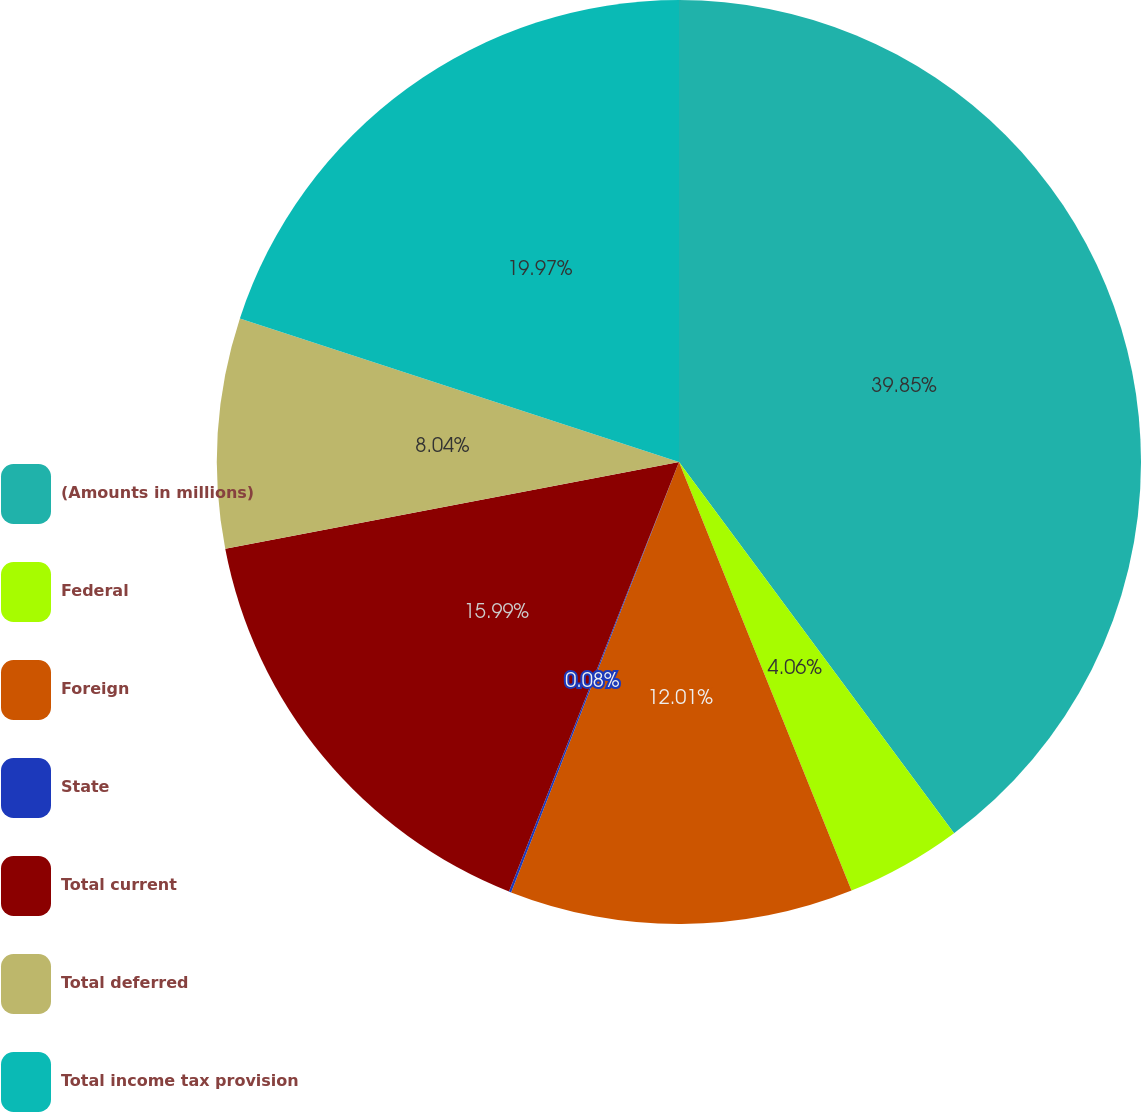Convert chart to OTSL. <chart><loc_0><loc_0><loc_500><loc_500><pie_chart><fcel>(Amounts in millions)<fcel>Federal<fcel>Foreign<fcel>State<fcel>Total current<fcel>Total deferred<fcel>Total income tax provision<nl><fcel>39.85%<fcel>4.06%<fcel>12.01%<fcel>0.08%<fcel>15.99%<fcel>8.04%<fcel>19.97%<nl></chart> 